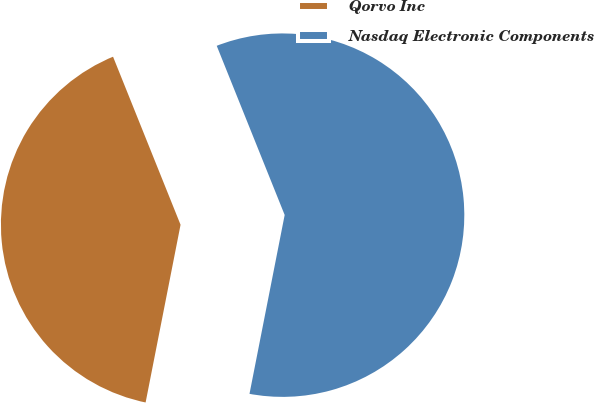<chart> <loc_0><loc_0><loc_500><loc_500><pie_chart><fcel>Qorvo Inc<fcel>Nasdaq Electronic Components<nl><fcel>40.83%<fcel>59.17%<nl></chart> 